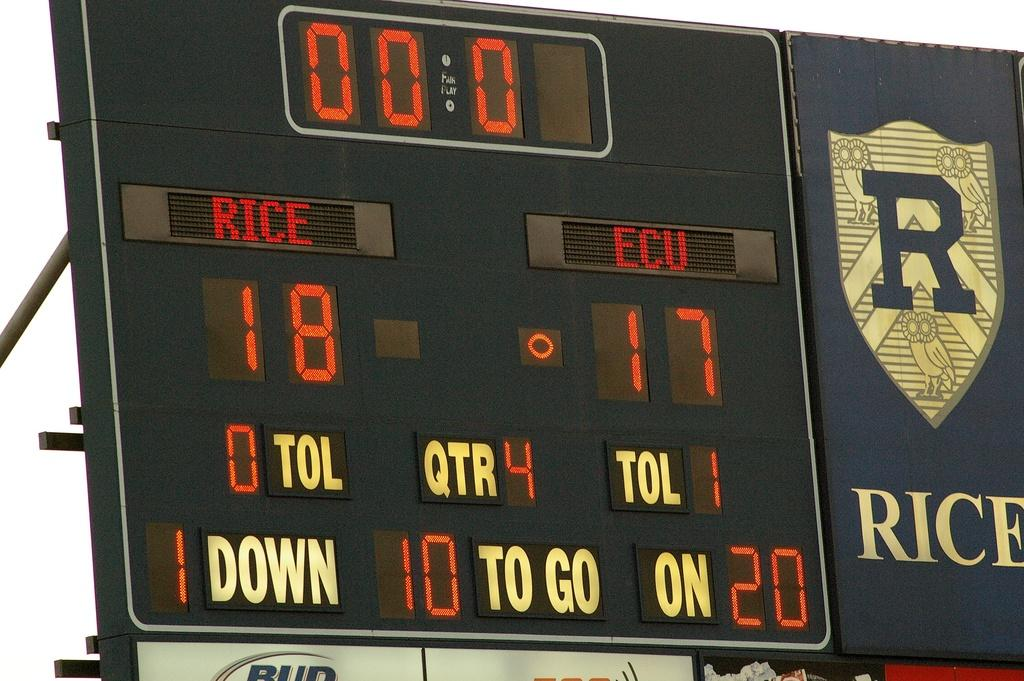Provide a one-sentence caption for the provided image. The scoreboard of a football game shoes that Rice is winning. 